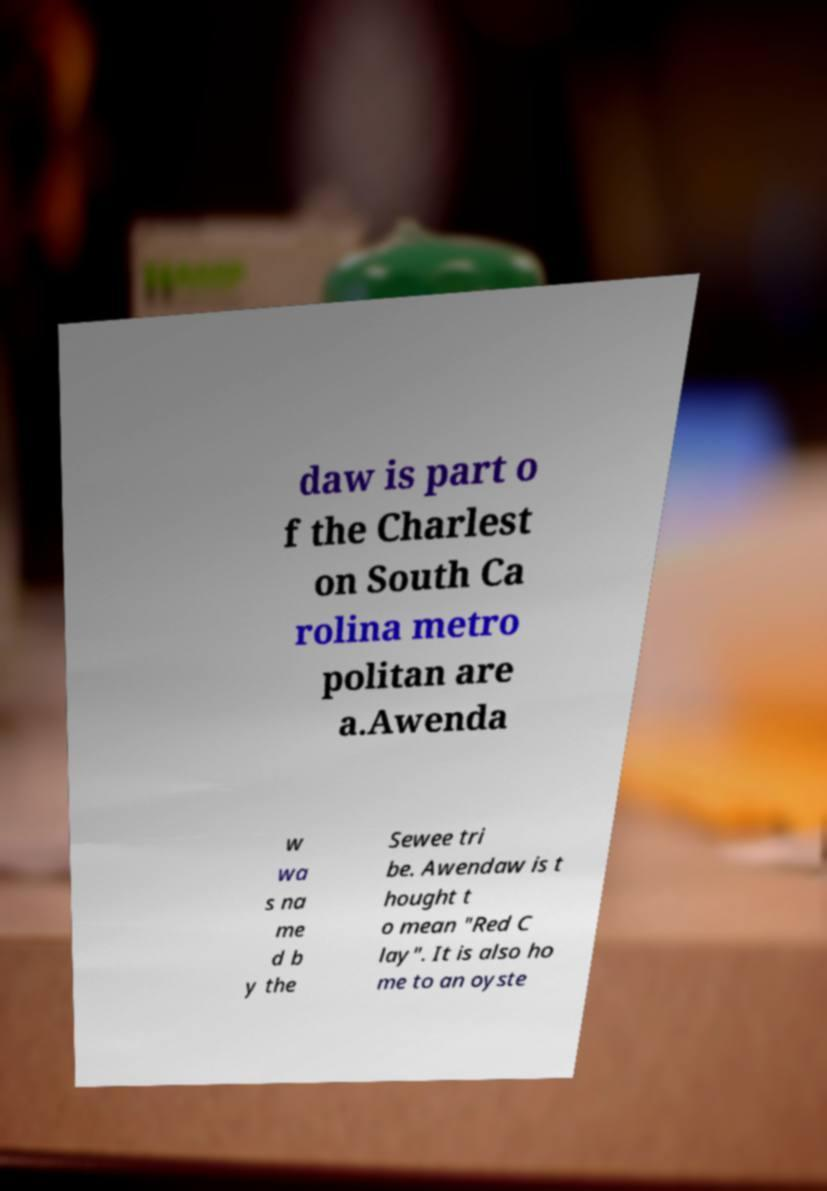Can you accurately transcribe the text from the provided image for me? daw is part o f the Charlest on South Ca rolina metro politan are a.Awenda w wa s na me d b y the Sewee tri be. Awendaw is t hought t o mean "Red C lay". It is also ho me to an oyste 